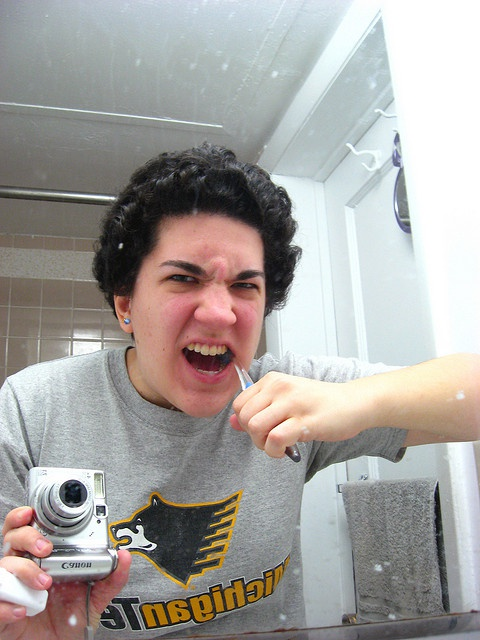Describe the objects in this image and their specific colors. I can see people in gray, darkgray, black, and ivory tones and toothbrush in gray, ivory, tan, and brown tones in this image. 